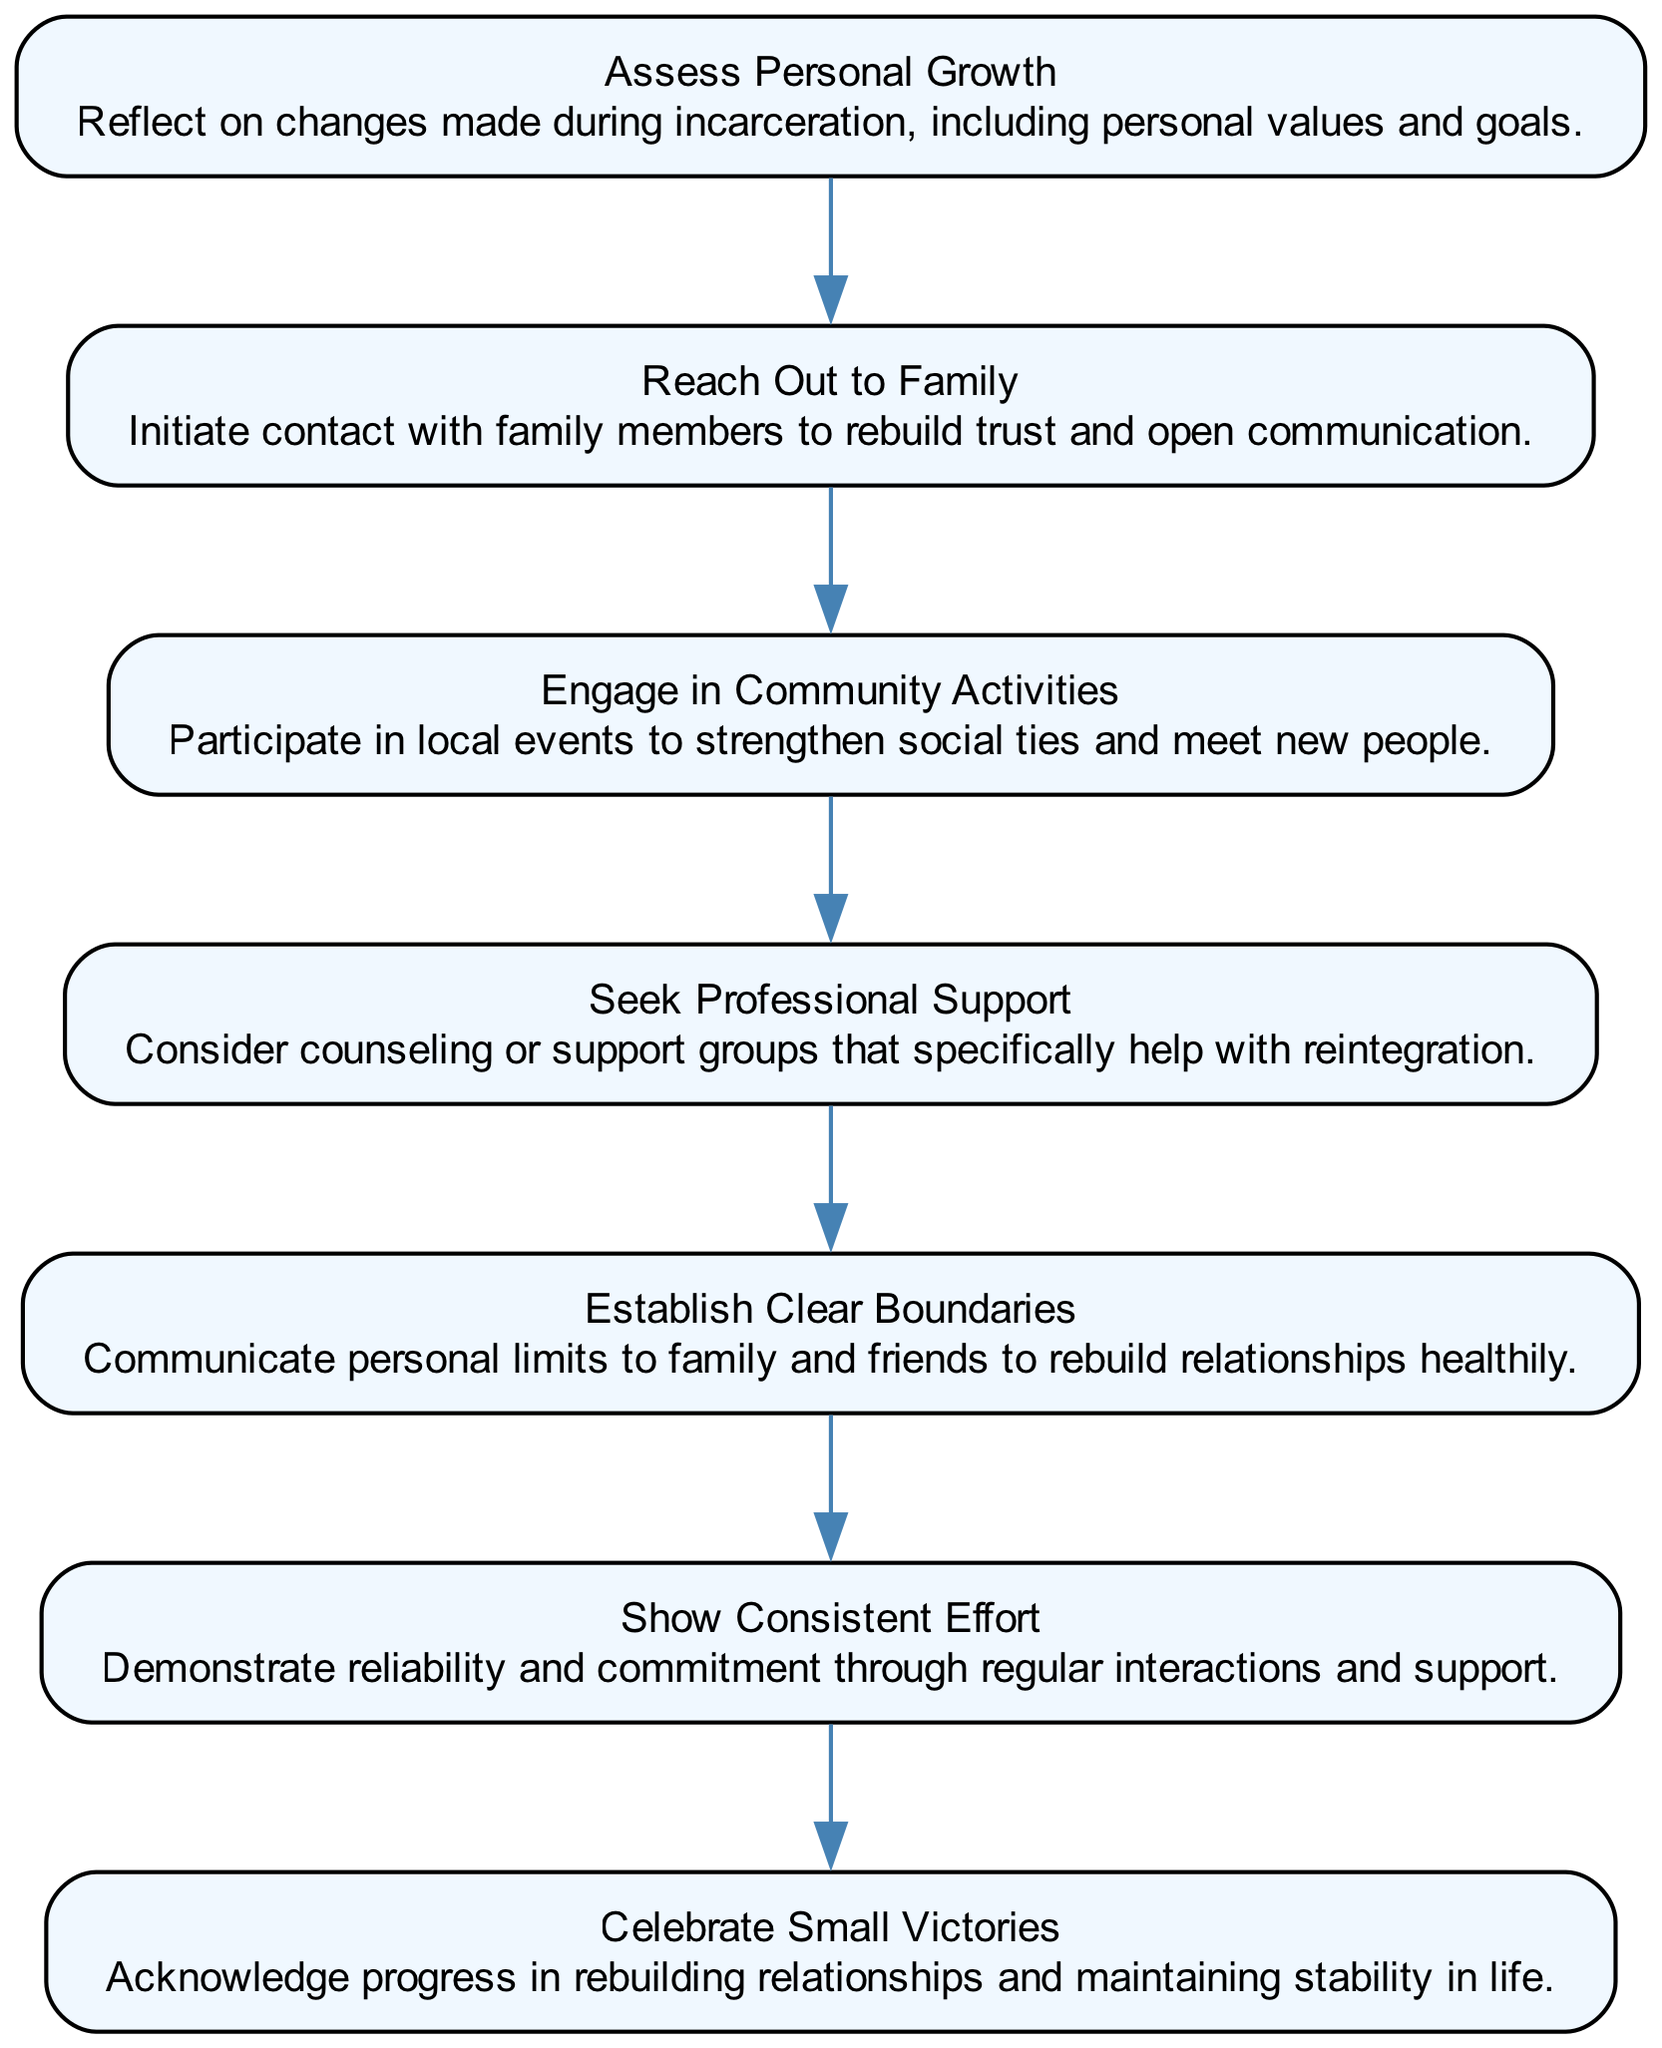What is the first step in the flow chart? The first step is identified as "Assess Personal Growth," which is the top node in the diagram. Since it's the first in the series, it is listed before all other steps.
Answer: Assess Personal Growth How many total steps are shown in the diagram? By counting each defined step listed in the flow chart, I find a total of seven distinct steps. Each step corresponds to a node connected in a sequence.
Answer: 7 What is the last step in the flow chart? The last step is identified as "Celebrate Small Victories," which is the bottom node in the diagram. It's the seventh step, connected from the previous one.
Answer: Celebrate Small Victories Which step comes after "Reach Out to Family"? "Engage in Community Activities" follows "Reach Out to Family" in the flow of the diagram. The connections between the nodes indicate the order.
Answer: Engage in Community Activities How many edges are present in the flow chart? Each step is connected to the next, creating a total of six edges. This is derived from the number of connections between the seven nodes; specifically, one less than the number of nodes.
Answer: 6 What is the focus of the fourth step? The fourth step focuses on seeking professional assistance by considering counseling or support groups designed for reintegration. This step is clearly labeled in the description.
Answer: Seek Professional Support What type of boundaries should be established according to the fifth step? Clear boundaries are emphasized in this step, indicating the need for effective communication of personal limits to others for healthy relationship rebuilding.
Answer: Clear Boundaries Which step is primarily about evaluating progress in relationships? "Celebrate Small Victories" is centered on acknowledging and valuing the gradual progress made in nurturing and rebuilding relationships over time.
Answer: Celebrate Small Victories 